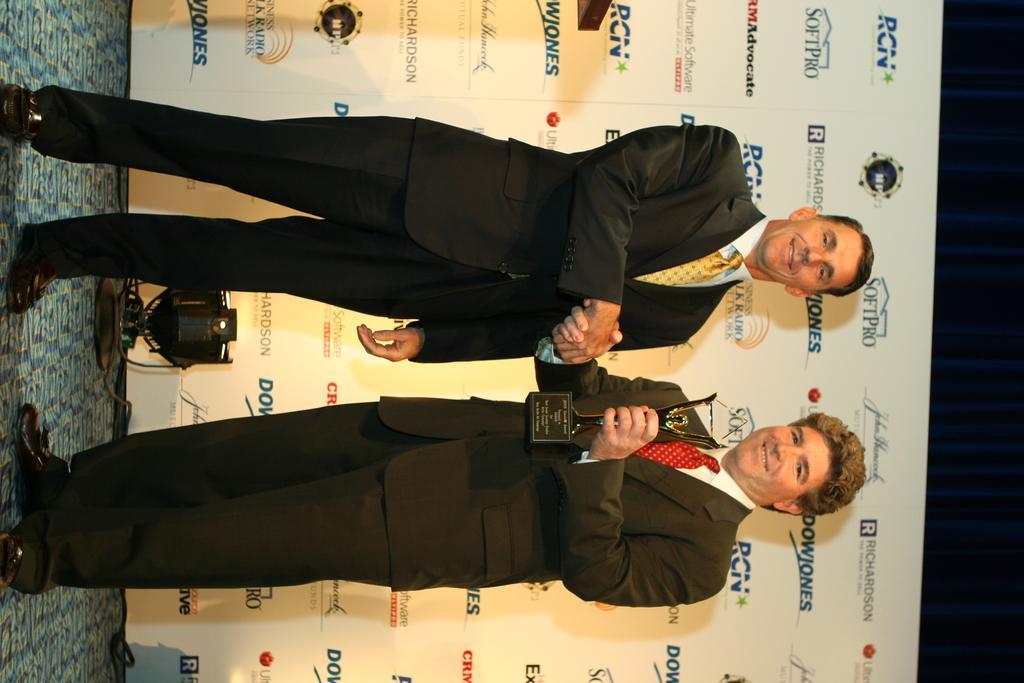How would you summarize this image in a sentence or two? In the middle of the picture we can see two persons standing. At the bottom the person is holding a trophy. Towards left we can see mat and there is a focus light. In the center there is a banner. On the right it is dark. 